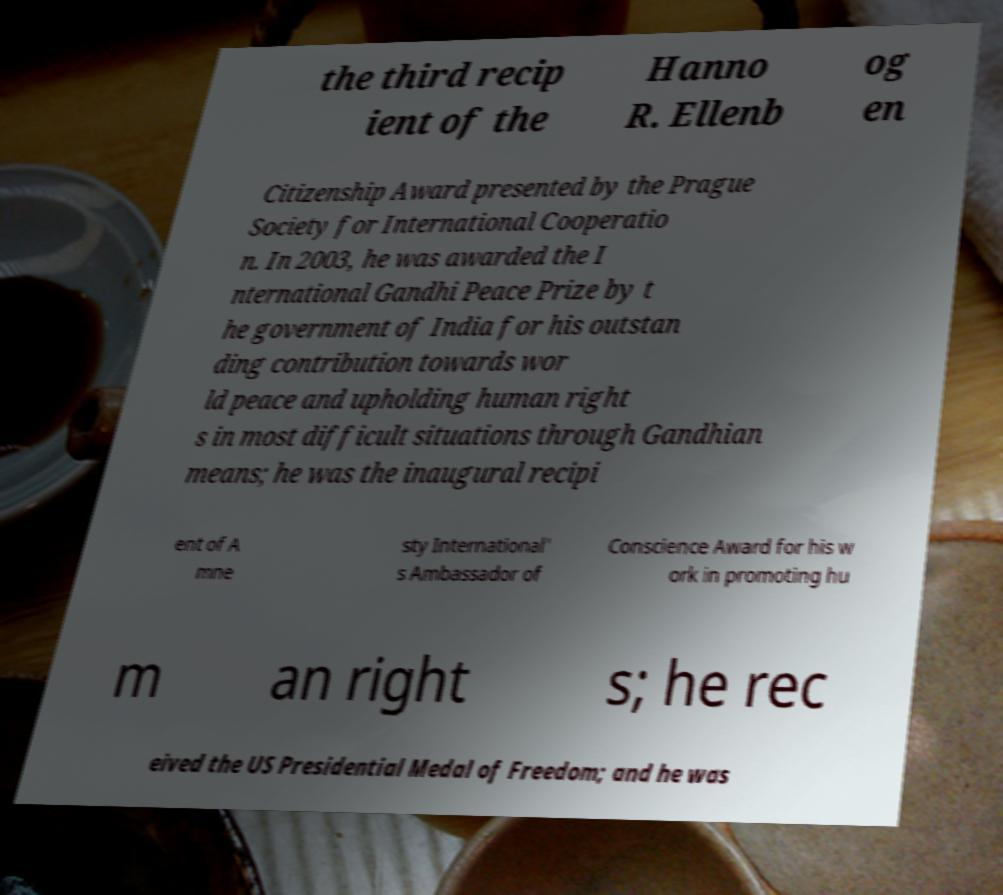Please read and relay the text visible in this image. What does it say? the third recip ient of the Hanno R. Ellenb og en Citizenship Award presented by the Prague Society for International Cooperatio n. In 2003, he was awarded the I nternational Gandhi Peace Prize by t he government of India for his outstan ding contribution towards wor ld peace and upholding human right s in most difficult situations through Gandhian means; he was the inaugural recipi ent of A mne sty International' s Ambassador of Conscience Award for his w ork in promoting hu m an right s; he rec eived the US Presidential Medal of Freedom; and he was 